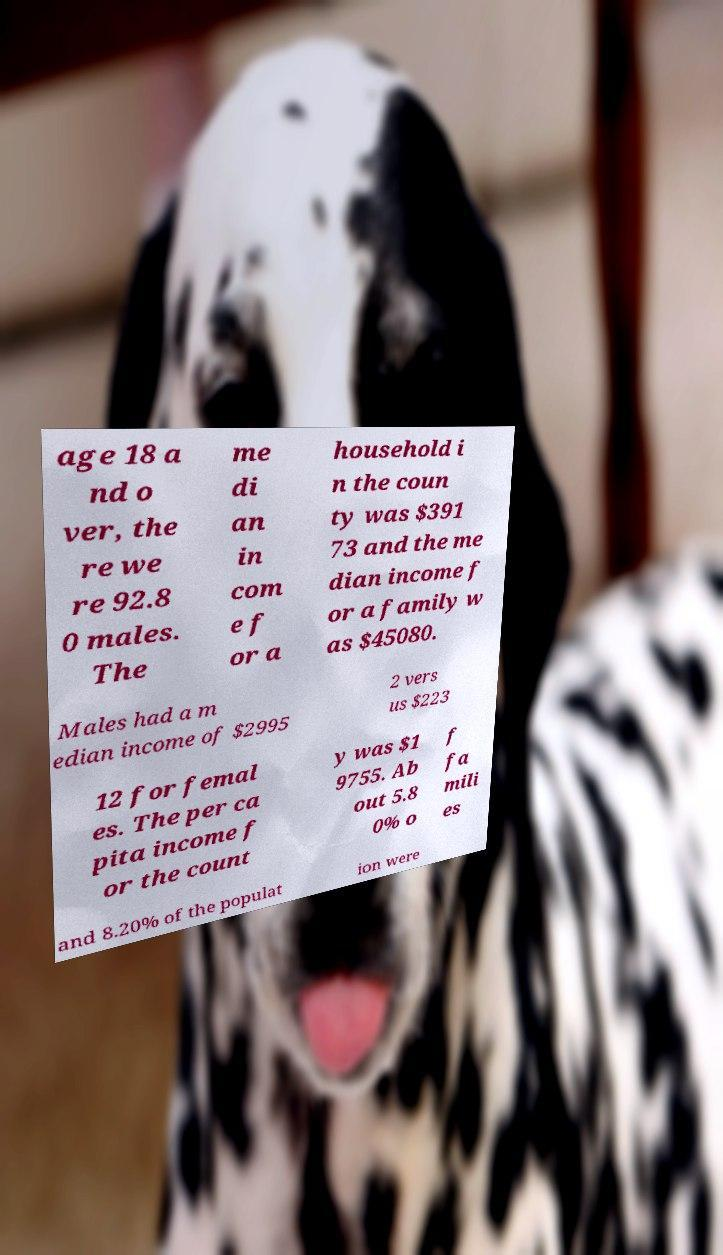Could you extract and type out the text from this image? age 18 a nd o ver, the re we re 92.8 0 males. The me di an in com e f or a household i n the coun ty was $391 73 and the me dian income f or a family w as $45080. Males had a m edian income of $2995 2 vers us $223 12 for femal es. The per ca pita income f or the count y was $1 9755. Ab out 5.8 0% o f fa mili es and 8.20% of the populat ion were 